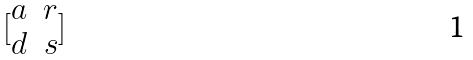<formula> <loc_0><loc_0><loc_500><loc_500>[ \begin{matrix} a & r \\ d & s \end{matrix} ]</formula> 